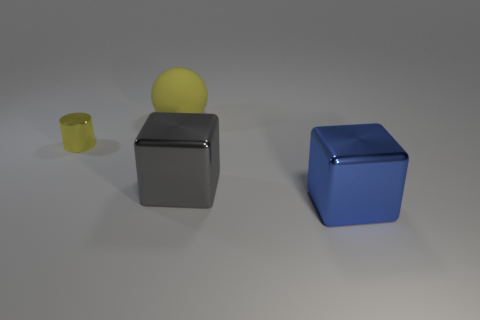What size is the thing that is left of the yellow thing on the right side of the thing that is left of the ball?
Keep it short and to the point. Small. Do the blue thing and the yellow sphere have the same size?
Your answer should be compact. Yes. How many objects are either small yellow shiny cylinders or blocks?
Your answer should be very brief. 3. How big is the yellow object that is to the left of the large thing that is behind the tiny cylinder?
Provide a succinct answer. Small. What is the size of the yellow cylinder?
Ensure brevity in your answer.  Small. The object that is to the right of the yellow metal object and on the left side of the big gray cube has what shape?
Provide a short and direct response. Sphere. The other object that is the same shape as the gray thing is what color?
Your answer should be very brief. Blue. What number of objects are blocks to the left of the blue cube or things on the right side of the small object?
Give a very brief answer. 3. What is the shape of the large rubber object?
Provide a short and direct response. Sphere. What is the shape of the object that is the same color as the matte ball?
Offer a very short reply. Cylinder. 